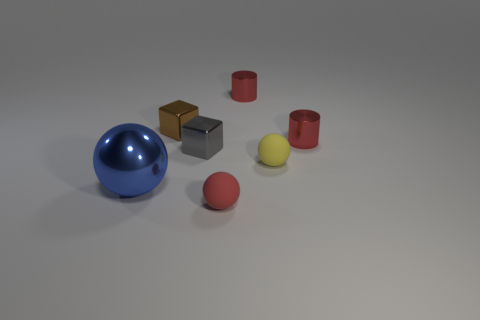Add 2 red metallic things. How many objects exist? 9 Subtract all spheres. How many objects are left? 4 Add 7 tiny red objects. How many tiny red objects are left? 10 Add 3 small brown rubber spheres. How many small brown rubber spheres exist? 3 Subtract 0 purple blocks. How many objects are left? 7 Subtract all tiny brown metallic things. Subtract all small red rubber things. How many objects are left? 5 